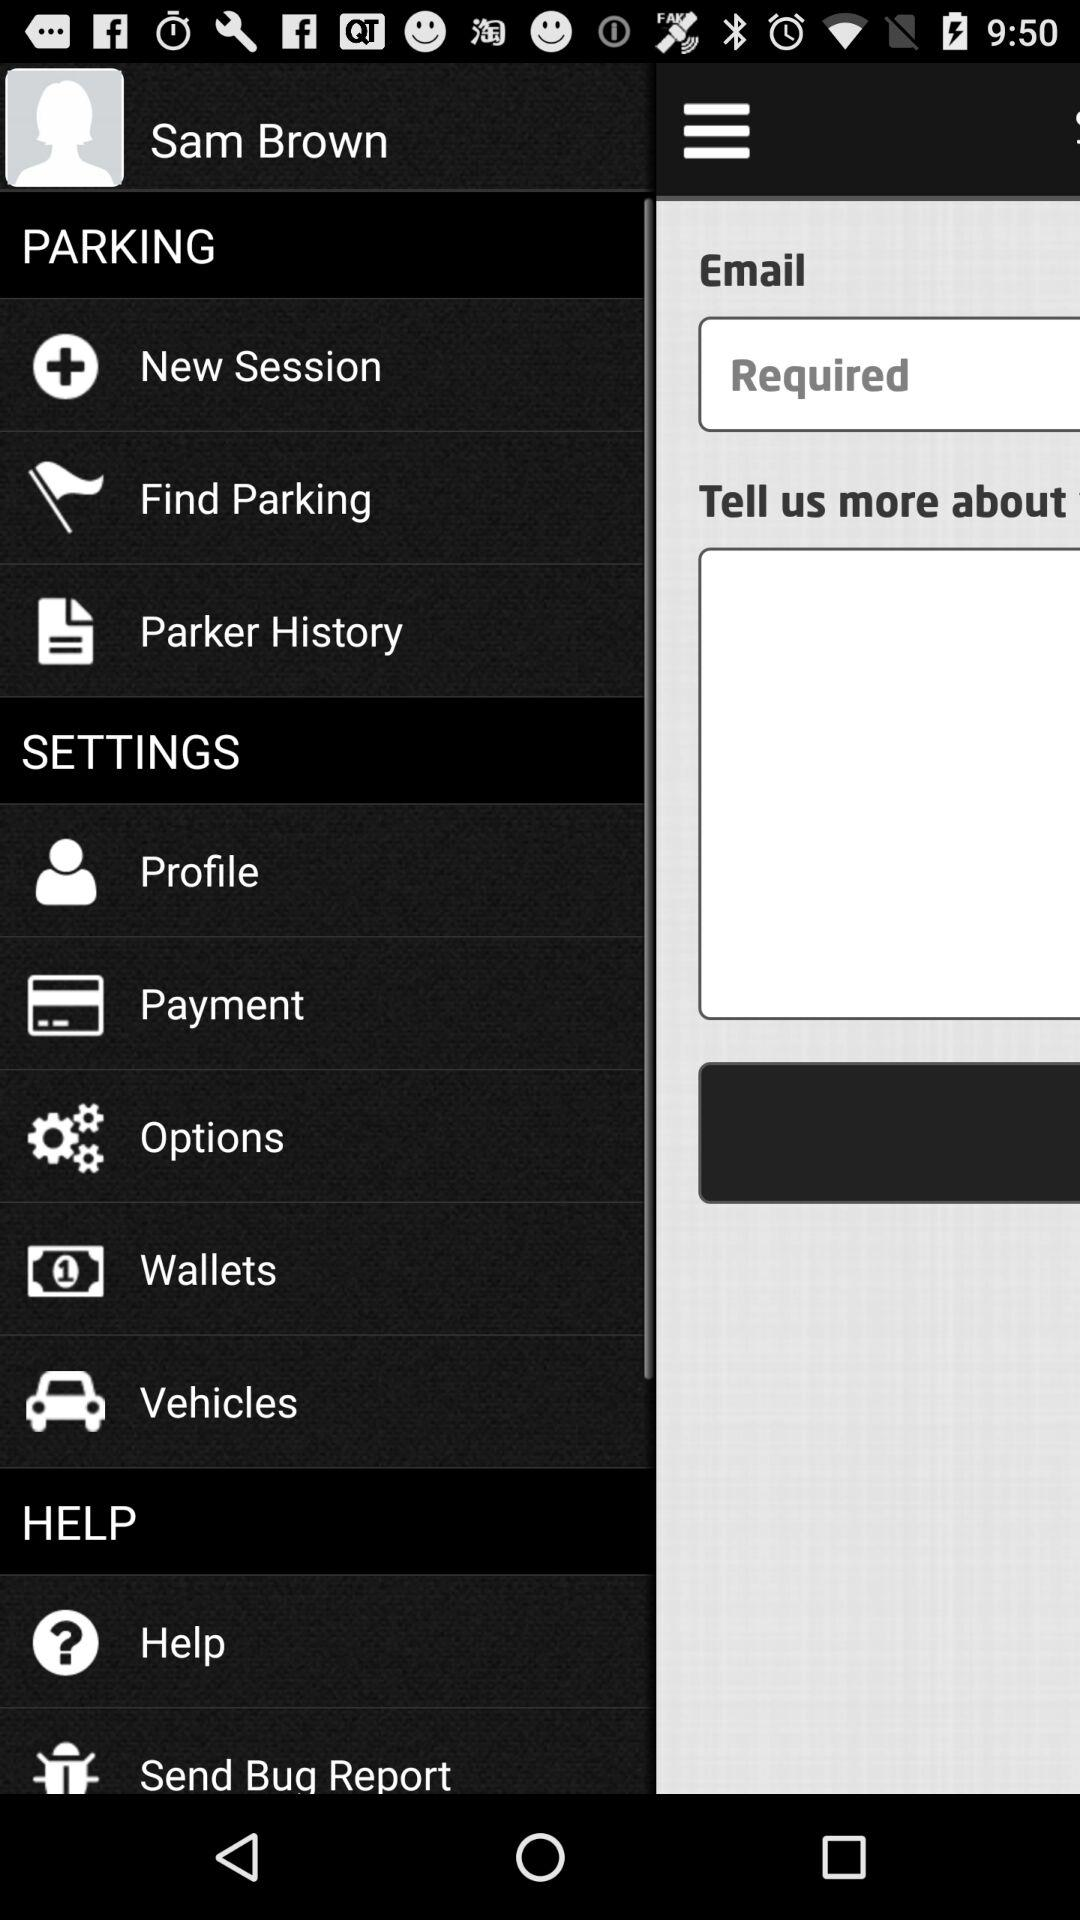What is the profile name? The profile name is Sam Brown. 